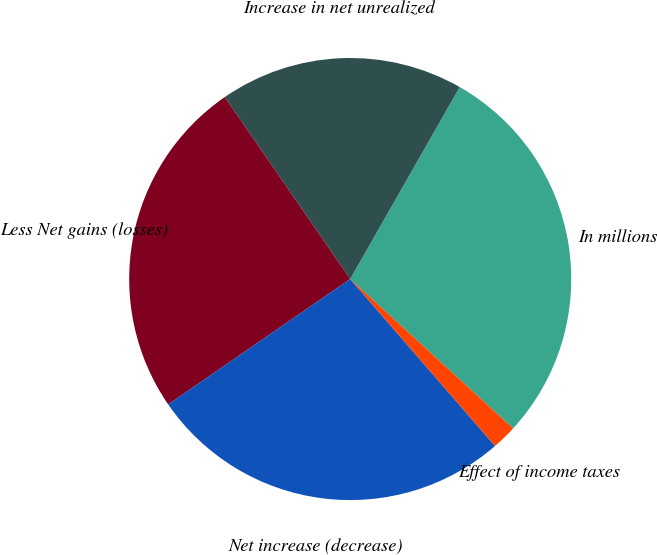<chart> <loc_0><loc_0><loc_500><loc_500><pie_chart><fcel>In millions<fcel>Increase in net unrealized<fcel>Less Net gains (losses)<fcel>Net increase (decrease)<fcel>Effect of income taxes<nl><fcel>28.56%<fcel>17.86%<fcel>24.99%<fcel>26.77%<fcel>1.82%<nl></chart> 